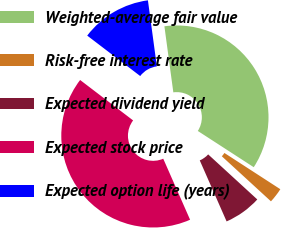Convert chart to OTSL. <chart><loc_0><loc_0><loc_500><loc_500><pie_chart><fcel>Weighted-average fair value<fcel>Risk-free interest rate<fcel>Expected dividend yield<fcel>Expected stock price<fcel>Expected option life (years)<nl><fcel>36.29%<fcel>2.66%<fcel>6.59%<fcel>41.97%<fcel>12.49%<nl></chart> 